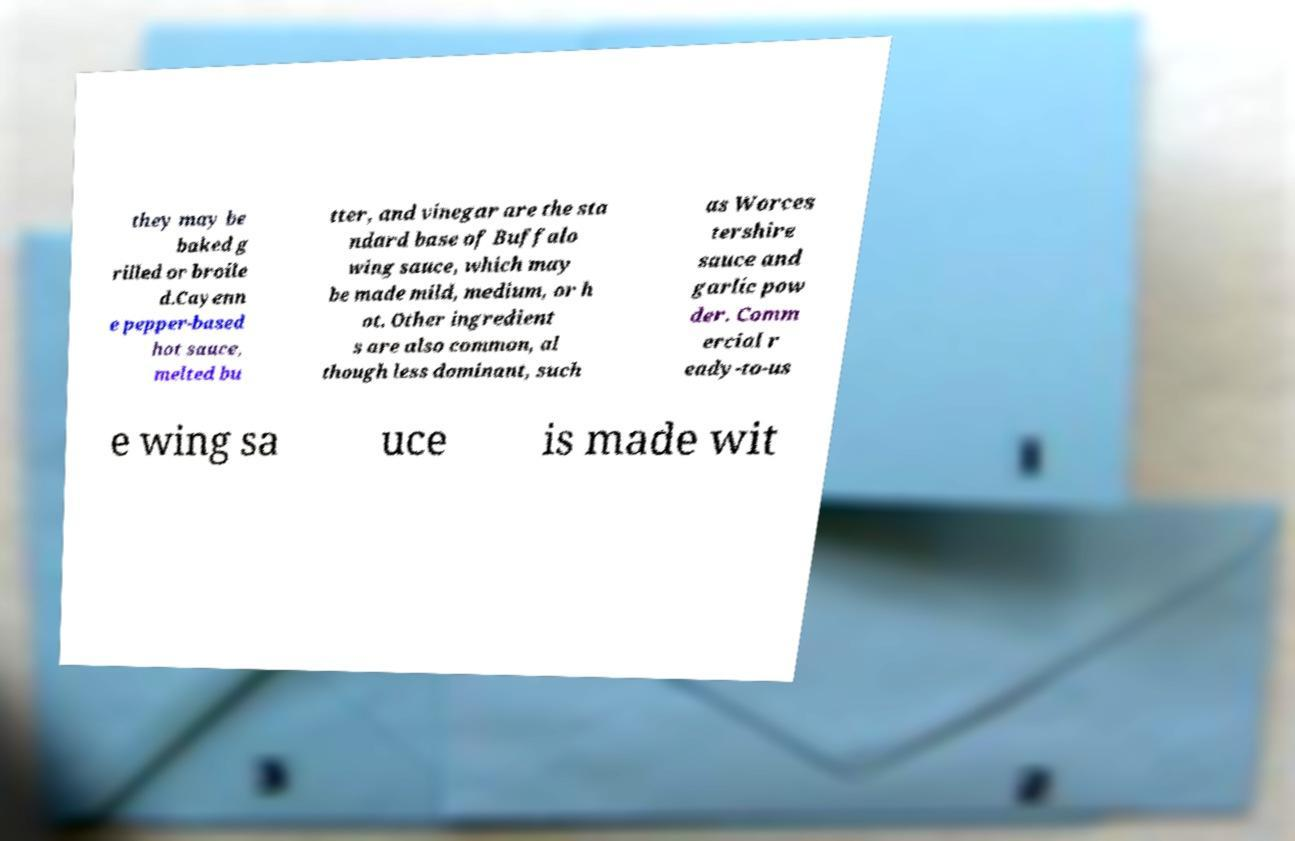I need the written content from this picture converted into text. Can you do that? they may be baked g rilled or broile d.Cayenn e pepper-based hot sauce, melted bu tter, and vinegar are the sta ndard base of Buffalo wing sauce, which may be made mild, medium, or h ot. Other ingredient s are also common, al though less dominant, such as Worces tershire sauce and garlic pow der. Comm ercial r eady-to-us e wing sa uce is made wit 